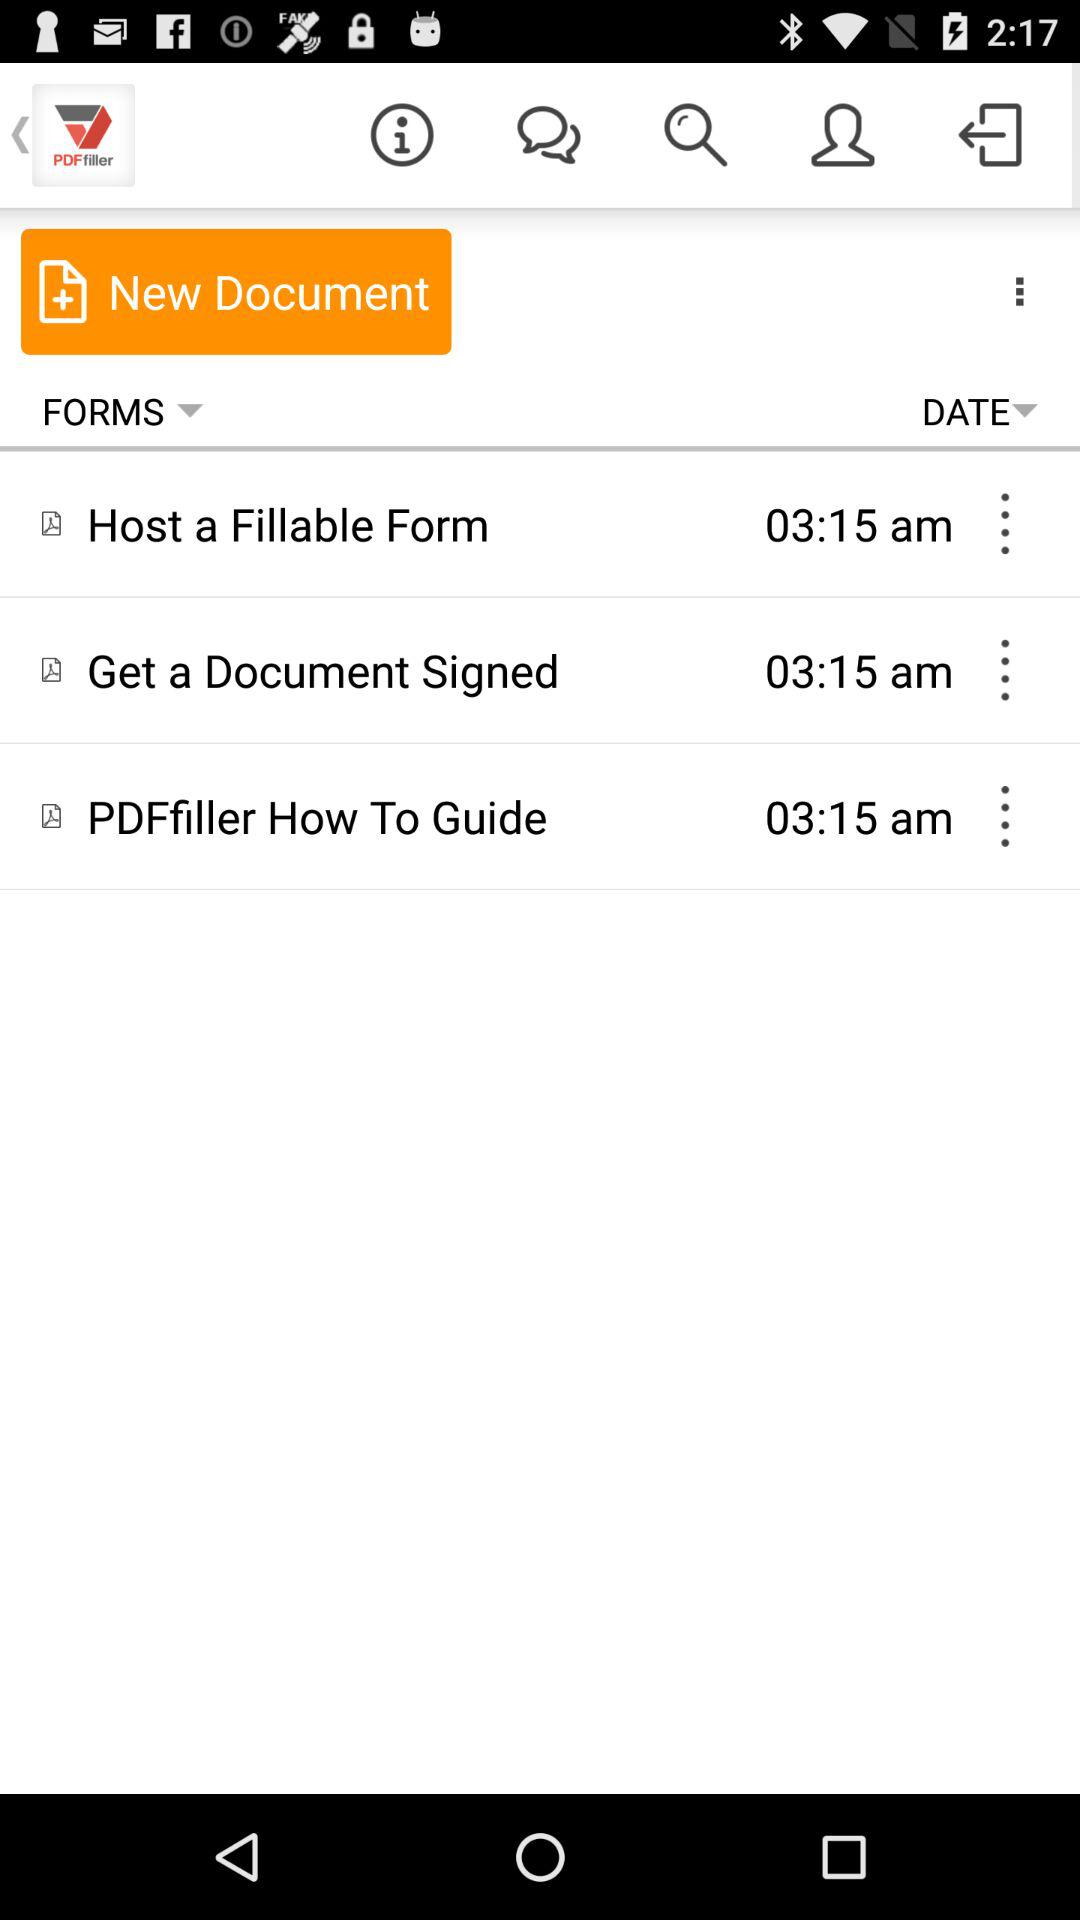How many unread messages are there?
When the provided information is insufficient, respond with <no answer>. <no answer> 